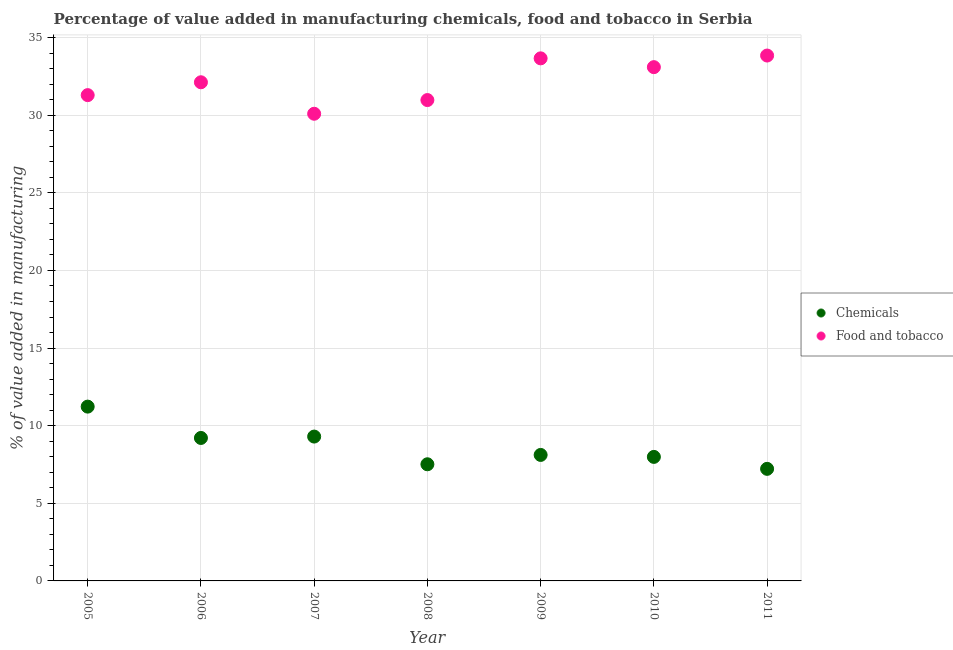Is the number of dotlines equal to the number of legend labels?
Ensure brevity in your answer.  Yes. What is the value added by  manufacturing chemicals in 2010?
Provide a succinct answer. 7.99. Across all years, what is the maximum value added by manufacturing food and tobacco?
Ensure brevity in your answer.  33.84. Across all years, what is the minimum value added by manufacturing food and tobacco?
Offer a terse response. 30.09. In which year was the value added by manufacturing food and tobacco minimum?
Provide a short and direct response. 2007. What is the total value added by  manufacturing chemicals in the graph?
Offer a terse response. 60.57. What is the difference between the value added by  manufacturing chemicals in 2005 and that in 2007?
Ensure brevity in your answer.  1.93. What is the difference between the value added by manufacturing food and tobacco in 2005 and the value added by  manufacturing chemicals in 2009?
Offer a terse response. 23.18. What is the average value added by manufacturing food and tobacco per year?
Offer a terse response. 32.15. In the year 2010, what is the difference between the value added by  manufacturing chemicals and value added by manufacturing food and tobacco?
Offer a very short reply. -25.11. What is the ratio of the value added by manufacturing food and tobacco in 2007 to that in 2010?
Provide a short and direct response. 0.91. Is the value added by  manufacturing chemicals in 2008 less than that in 2011?
Give a very brief answer. No. Is the difference between the value added by  manufacturing chemicals in 2008 and 2009 greater than the difference between the value added by manufacturing food and tobacco in 2008 and 2009?
Ensure brevity in your answer.  Yes. What is the difference between the highest and the second highest value added by  manufacturing chemicals?
Provide a succinct answer. 1.93. What is the difference between the highest and the lowest value added by  manufacturing chemicals?
Your answer should be very brief. 4.01. In how many years, is the value added by manufacturing food and tobacco greater than the average value added by manufacturing food and tobacco taken over all years?
Your response must be concise. 3. How many dotlines are there?
Offer a terse response. 2. Does the graph contain any zero values?
Your answer should be very brief. No. Does the graph contain grids?
Provide a succinct answer. Yes. How are the legend labels stacked?
Your response must be concise. Vertical. What is the title of the graph?
Your response must be concise. Percentage of value added in manufacturing chemicals, food and tobacco in Serbia. What is the label or title of the Y-axis?
Give a very brief answer. % of value added in manufacturing. What is the % of value added in manufacturing in Chemicals in 2005?
Ensure brevity in your answer.  11.23. What is the % of value added in manufacturing of Food and tobacco in 2005?
Your answer should be very brief. 31.29. What is the % of value added in manufacturing in Chemicals in 2006?
Provide a succinct answer. 9.21. What is the % of value added in manufacturing in Food and tobacco in 2006?
Your answer should be very brief. 32.12. What is the % of value added in manufacturing in Chemicals in 2007?
Your answer should be compact. 9.3. What is the % of value added in manufacturing in Food and tobacco in 2007?
Provide a short and direct response. 30.09. What is the % of value added in manufacturing of Chemicals in 2008?
Your answer should be very brief. 7.51. What is the % of value added in manufacturing of Food and tobacco in 2008?
Your answer should be very brief. 30.97. What is the % of value added in manufacturing in Chemicals in 2009?
Offer a very short reply. 8.12. What is the % of value added in manufacturing of Food and tobacco in 2009?
Your answer should be compact. 33.66. What is the % of value added in manufacturing of Chemicals in 2010?
Offer a very short reply. 7.99. What is the % of value added in manufacturing in Food and tobacco in 2010?
Keep it short and to the point. 33.09. What is the % of value added in manufacturing in Chemicals in 2011?
Provide a succinct answer. 7.22. What is the % of value added in manufacturing in Food and tobacco in 2011?
Provide a short and direct response. 33.84. Across all years, what is the maximum % of value added in manufacturing in Chemicals?
Your response must be concise. 11.23. Across all years, what is the maximum % of value added in manufacturing of Food and tobacco?
Provide a short and direct response. 33.84. Across all years, what is the minimum % of value added in manufacturing of Chemicals?
Your response must be concise. 7.22. Across all years, what is the minimum % of value added in manufacturing in Food and tobacco?
Keep it short and to the point. 30.09. What is the total % of value added in manufacturing in Chemicals in the graph?
Offer a very short reply. 60.57. What is the total % of value added in manufacturing of Food and tobacco in the graph?
Provide a short and direct response. 225.08. What is the difference between the % of value added in manufacturing in Chemicals in 2005 and that in 2006?
Your answer should be compact. 2.02. What is the difference between the % of value added in manufacturing in Food and tobacco in 2005 and that in 2006?
Offer a terse response. -0.83. What is the difference between the % of value added in manufacturing in Chemicals in 2005 and that in 2007?
Your answer should be compact. 1.93. What is the difference between the % of value added in manufacturing of Food and tobacco in 2005 and that in 2007?
Your answer should be compact. 1.2. What is the difference between the % of value added in manufacturing of Chemicals in 2005 and that in 2008?
Your response must be concise. 3.71. What is the difference between the % of value added in manufacturing in Food and tobacco in 2005 and that in 2008?
Offer a terse response. 0.32. What is the difference between the % of value added in manufacturing in Chemicals in 2005 and that in 2009?
Give a very brief answer. 3.11. What is the difference between the % of value added in manufacturing in Food and tobacco in 2005 and that in 2009?
Offer a very short reply. -2.37. What is the difference between the % of value added in manufacturing of Chemicals in 2005 and that in 2010?
Provide a succinct answer. 3.24. What is the difference between the % of value added in manufacturing in Food and tobacco in 2005 and that in 2010?
Ensure brevity in your answer.  -1.8. What is the difference between the % of value added in manufacturing in Chemicals in 2005 and that in 2011?
Your answer should be compact. 4.01. What is the difference between the % of value added in manufacturing in Food and tobacco in 2005 and that in 2011?
Provide a short and direct response. -2.55. What is the difference between the % of value added in manufacturing in Chemicals in 2006 and that in 2007?
Keep it short and to the point. -0.09. What is the difference between the % of value added in manufacturing of Food and tobacco in 2006 and that in 2007?
Offer a terse response. 2.03. What is the difference between the % of value added in manufacturing in Chemicals in 2006 and that in 2008?
Ensure brevity in your answer.  1.7. What is the difference between the % of value added in manufacturing in Food and tobacco in 2006 and that in 2008?
Your answer should be very brief. 1.15. What is the difference between the % of value added in manufacturing of Chemicals in 2006 and that in 2009?
Offer a very short reply. 1.09. What is the difference between the % of value added in manufacturing in Food and tobacco in 2006 and that in 2009?
Give a very brief answer. -1.54. What is the difference between the % of value added in manufacturing of Chemicals in 2006 and that in 2010?
Make the answer very short. 1.22. What is the difference between the % of value added in manufacturing of Food and tobacco in 2006 and that in 2010?
Offer a very short reply. -0.97. What is the difference between the % of value added in manufacturing in Chemicals in 2006 and that in 2011?
Your response must be concise. 1.99. What is the difference between the % of value added in manufacturing in Food and tobacco in 2006 and that in 2011?
Make the answer very short. -1.72. What is the difference between the % of value added in manufacturing in Chemicals in 2007 and that in 2008?
Your response must be concise. 1.78. What is the difference between the % of value added in manufacturing in Food and tobacco in 2007 and that in 2008?
Ensure brevity in your answer.  -0.88. What is the difference between the % of value added in manufacturing of Chemicals in 2007 and that in 2009?
Keep it short and to the point. 1.18. What is the difference between the % of value added in manufacturing in Food and tobacco in 2007 and that in 2009?
Provide a succinct answer. -3.57. What is the difference between the % of value added in manufacturing in Chemicals in 2007 and that in 2010?
Your response must be concise. 1.31. What is the difference between the % of value added in manufacturing in Food and tobacco in 2007 and that in 2010?
Your answer should be compact. -3. What is the difference between the % of value added in manufacturing of Chemicals in 2007 and that in 2011?
Your answer should be compact. 2.08. What is the difference between the % of value added in manufacturing of Food and tobacco in 2007 and that in 2011?
Your answer should be compact. -3.75. What is the difference between the % of value added in manufacturing of Chemicals in 2008 and that in 2009?
Offer a very short reply. -0.6. What is the difference between the % of value added in manufacturing of Food and tobacco in 2008 and that in 2009?
Provide a succinct answer. -2.69. What is the difference between the % of value added in manufacturing of Chemicals in 2008 and that in 2010?
Your response must be concise. -0.48. What is the difference between the % of value added in manufacturing in Food and tobacco in 2008 and that in 2010?
Provide a short and direct response. -2.12. What is the difference between the % of value added in manufacturing of Chemicals in 2008 and that in 2011?
Make the answer very short. 0.29. What is the difference between the % of value added in manufacturing in Food and tobacco in 2008 and that in 2011?
Provide a succinct answer. -2.87. What is the difference between the % of value added in manufacturing in Chemicals in 2009 and that in 2010?
Give a very brief answer. 0.13. What is the difference between the % of value added in manufacturing of Food and tobacco in 2009 and that in 2010?
Your answer should be compact. 0.57. What is the difference between the % of value added in manufacturing in Chemicals in 2009 and that in 2011?
Keep it short and to the point. 0.9. What is the difference between the % of value added in manufacturing of Food and tobacco in 2009 and that in 2011?
Provide a succinct answer. -0.18. What is the difference between the % of value added in manufacturing in Chemicals in 2010 and that in 2011?
Your response must be concise. 0.77. What is the difference between the % of value added in manufacturing in Food and tobacco in 2010 and that in 2011?
Ensure brevity in your answer.  -0.75. What is the difference between the % of value added in manufacturing in Chemicals in 2005 and the % of value added in manufacturing in Food and tobacco in 2006?
Offer a terse response. -20.89. What is the difference between the % of value added in manufacturing in Chemicals in 2005 and the % of value added in manufacturing in Food and tobacco in 2007?
Provide a succinct answer. -18.87. What is the difference between the % of value added in manufacturing in Chemicals in 2005 and the % of value added in manufacturing in Food and tobacco in 2008?
Make the answer very short. -19.75. What is the difference between the % of value added in manufacturing of Chemicals in 2005 and the % of value added in manufacturing of Food and tobacco in 2009?
Give a very brief answer. -22.43. What is the difference between the % of value added in manufacturing of Chemicals in 2005 and the % of value added in manufacturing of Food and tobacco in 2010?
Ensure brevity in your answer.  -21.87. What is the difference between the % of value added in manufacturing in Chemicals in 2005 and the % of value added in manufacturing in Food and tobacco in 2011?
Offer a very short reply. -22.61. What is the difference between the % of value added in manufacturing of Chemicals in 2006 and the % of value added in manufacturing of Food and tobacco in 2007?
Give a very brief answer. -20.88. What is the difference between the % of value added in manufacturing of Chemicals in 2006 and the % of value added in manufacturing of Food and tobacco in 2008?
Your answer should be compact. -21.77. What is the difference between the % of value added in manufacturing in Chemicals in 2006 and the % of value added in manufacturing in Food and tobacco in 2009?
Keep it short and to the point. -24.45. What is the difference between the % of value added in manufacturing in Chemicals in 2006 and the % of value added in manufacturing in Food and tobacco in 2010?
Keep it short and to the point. -23.89. What is the difference between the % of value added in manufacturing of Chemicals in 2006 and the % of value added in manufacturing of Food and tobacco in 2011?
Offer a very short reply. -24.63. What is the difference between the % of value added in manufacturing in Chemicals in 2007 and the % of value added in manufacturing in Food and tobacco in 2008?
Provide a succinct answer. -21.68. What is the difference between the % of value added in manufacturing of Chemicals in 2007 and the % of value added in manufacturing of Food and tobacco in 2009?
Keep it short and to the point. -24.36. What is the difference between the % of value added in manufacturing in Chemicals in 2007 and the % of value added in manufacturing in Food and tobacco in 2010?
Ensure brevity in your answer.  -23.8. What is the difference between the % of value added in manufacturing in Chemicals in 2007 and the % of value added in manufacturing in Food and tobacco in 2011?
Keep it short and to the point. -24.54. What is the difference between the % of value added in manufacturing of Chemicals in 2008 and the % of value added in manufacturing of Food and tobacco in 2009?
Provide a short and direct response. -26.15. What is the difference between the % of value added in manufacturing of Chemicals in 2008 and the % of value added in manufacturing of Food and tobacco in 2010?
Give a very brief answer. -25.58. What is the difference between the % of value added in manufacturing of Chemicals in 2008 and the % of value added in manufacturing of Food and tobacco in 2011?
Provide a succinct answer. -26.33. What is the difference between the % of value added in manufacturing of Chemicals in 2009 and the % of value added in manufacturing of Food and tobacco in 2010?
Ensure brevity in your answer.  -24.98. What is the difference between the % of value added in manufacturing of Chemicals in 2009 and the % of value added in manufacturing of Food and tobacco in 2011?
Your answer should be very brief. -25.73. What is the difference between the % of value added in manufacturing of Chemicals in 2010 and the % of value added in manufacturing of Food and tobacco in 2011?
Your response must be concise. -25.85. What is the average % of value added in manufacturing in Chemicals per year?
Give a very brief answer. 8.65. What is the average % of value added in manufacturing of Food and tobacco per year?
Make the answer very short. 32.15. In the year 2005, what is the difference between the % of value added in manufacturing of Chemicals and % of value added in manufacturing of Food and tobacco?
Provide a short and direct response. -20.07. In the year 2006, what is the difference between the % of value added in manufacturing in Chemicals and % of value added in manufacturing in Food and tobacco?
Your answer should be compact. -22.91. In the year 2007, what is the difference between the % of value added in manufacturing in Chemicals and % of value added in manufacturing in Food and tobacco?
Your response must be concise. -20.79. In the year 2008, what is the difference between the % of value added in manufacturing in Chemicals and % of value added in manufacturing in Food and tobacco?
Your answer should be very brief. -23.46. In the year 2009, what is the difference between the % of value added in manufacturing in Chemicals and % of value added in manufacturing in Food and tobacco?
Make the answer very short. -25.55. In the year 2010, what is the difference between the % of value added in manufacturing of Chemicals and % of value added in manufacturing of Food and tobacco?
Offer a terse response. -25.11. In the year 2011, what is the difference between the % of value added in manufacturing of Chemicals and % of value added in manufacturing of Food and tobacco?
Give a very brief answer. -26.62. What is the ratio of the % of value added in manufacturing in Chemicals in 2005 to that in 2006?
Offer a terse response. 1.22. What is the ratio of the % of value added in manufacturing of Food and tobacco in 2005 to that in 2006?
Your response must be concise. 0.97. What is the ratio of the % of value added in manufacturing in Chemicals in 2005 to that in 2007?
Provide a short and direct response. 1.21. What is the ratio of the % of value added in manufacturing of Food and tobacco in 2005 to that in 2007?
Offer a very short reply. 1.04. What is the ratio of the % of value added in manufacturing of Chemicals in 2005 to that in 2008?
Your answer should be very brief. 1.49. What is the ratio of the % of value added in manufacturing of Food and tobacco in 2005 to that in 2008?
Provide a succinct answer. 1.01. What is the ratio of the % of value added in manufacturing in Chemicals in 2005 to that in 2009?
Give a very brief answer. 1.38. What is the ratio of the % of value added in manufacturing of Food and tobacco in 2005 to that in 2009?
Offer a very short reply. 0.93. What is the ratio of the % of value added in manufacturing of Chemicals in 2005 to that in 2010?
Make the answer very short. 1.41. What is the ratio of the % of value added in manufacturing of Food and tobacco in 2005 to that in 2010?
Your response must be concise. 0.95. What is the ratio of the % of value added in manufacturing of Chemicals in 2005 to that in 2011?
Keep it short and to the point. 1.56. What is the ratio of the % of value added in manufacturing of Food and tobacco in 2005 to that in 2011?
Offer a terse response. 0.92. What is the ratio of the % of value added in manufacturing in Food and tobacco in 2006 to that in 2007?
Your answer should be compact. 1.07. What is the ratio of the % of value added in manufacturing of Chemicals in 2006 to that in 2008?
Your response must be concise. 1.23. What is the ratio of the % of value added in manufacturing in Chemicals in 2006 to that in 2009?
Offer a terse response. 1.13. What is the ratio of the % of value added in manufacturing of Food and tobacco in 2006 to that in 2009?
Offer a terse response. 0.95. What is the ratio of the % of value added in manufacturing of Chemicals in 2006 to that in 2010?
Offer a terse response. 1.15. What is the ratio of the % of value added in manufacturing in Food and tobacco in 2006 to that in 2010?
Give a very brief answer. 0.97. What is the ratio of the % of value added in manufacturing in Chemicals in 2006 to that in 2011?
Keep it short and to the point. 1.28. What is the ratio of the % of value added in manufacturing in Food and tobacco in 2006 to that in 2011?
Give a very brief answer. 0.95. What is the ratio of the % of value added in manufacturing of Chemicals in 2007 to that in 2008?
Your answer should be compact. 1.24. What is the ratio of the % of value added in manufacturing in Food and tobacco in 2007 to that in 2008?
Provide a succinct answer. 0.97. What is the ratio of the % of value added in manufacturing in Chemicals in 2007 to that in 2009?
Give a very brief answer. 1.15. What is the ratio of the % of value added in manufacturing of Food and tobacco in 2007 to that in 2009?
Provide a succinct answer. 0.89. What is the ratio of the % of value added in manufacturing of Chemicals in 2007 to that in 2010?
Keep it short and to the point. 1.16. What is the ratio of the % of value added in manufacturing in Food and tobacco in 2007 to that in 2010?
Your response must be concise. 0.91. What is the ratio of the % of value added in manufacturing in Chemicals in 2007 to that in 2011?
Keep it short and to the point. 1.29. What is the ratio of the % of value added in manufacturing in Food and tobacco in 2007 to that in 2011?
Provide a succinct answer. 0.89. What is the ratio of the % of value added in manufacturing of Chemicals in 2008 to that in 2009?
Your answer should be compact. 0.93. What is the ratio of the % of value added in manufacturing in Food and tobacco in 2008 to that in 2009?
Ensure brevity in your answer.  0.92. What is the ratio of the % of value added in manufacturing of Chemicals in 2008 to that in 2010?
Your answer should be compact. 0.94. What is the ratio of the % of value added in manufacturing in Food and tobacco in 2008 to that in 2010?
Offer a very short reply. 0.94. What is the ratio of the % of value added in manufacturing of Chemicals in 2008 to that in 2011?
Your answer should be very brief. 1.04. What is the ratio of the % of value added in manufacturing in Food and tobacco in 2008 to that in 2011?
Provide a succinct answer. 0.92. What is the ratio of the % of value added in manufacturing of Chemicals in 2009 to that in 2010?
Make the answer very short. 1.02. What is the ratio of the % of value added in manufacturing in Food and tobacco in 2009 to that in 2010?
Keep it short and to the point. 1.02. What is the ratio of the % of value added in manufacturing of Chemicals in 2009 to that in 2011?
Your response must be concise. 1.12. What is the ratio of the % of value added in manufacturing of Food and tobacco in 2009 to that in 2011?
Your answer should be very brief. 0.99. What is the ratio of the % of value added in manufacturing in Chemicals in 2010 to that in 2011?
Offer a very short reply. 1.11. What is the ratio of the % of value added in manufacturing of Food and tobacco in 2010 to that in 2011?
Give a very brief answer. 0.98. What is the difference between the highest and the second highest % of value added in manufacturing in Chemicals?
Offer a very short reply. 1.93. What is the difference between the highest and the second highest % of value added in manufacturing of Food and tobacco?
Your answer should be compact. 0.18. What is the difference between the highest and the lowest % of value added in manufacturing in Chemicals?
Provide a short and direct response. 4.01. What is the difference between the highest and the lowest % of value added in manufacturing of Food and tobacco?
Offer a terse response. 3.75. 